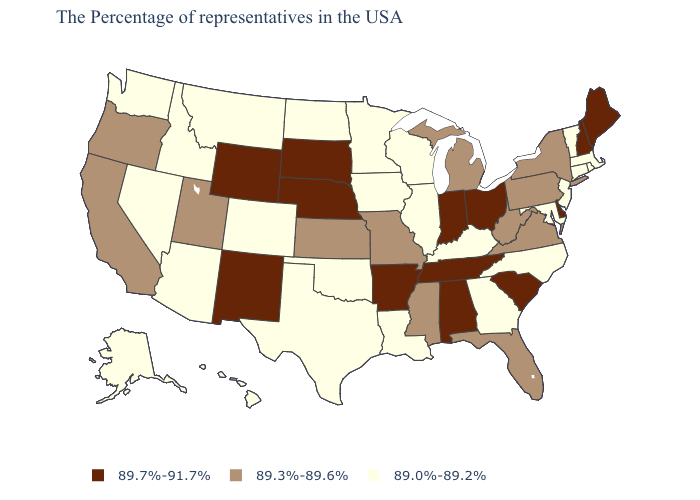Does Pennsylvania have the same value as Minnesota?
Concise answer only. No. Name the states that have a value in the range 89.3%-89.6%?
Give a very brief answer. New York, Pennsylvania, Virginia, West Virginia, Florida, Michigan, Mississippi, Missouri, Kansas, Utah, California, Oregon. What is the value of Wisconsin?
Be succinct. 89.0%-89.2%. How many symbols are there in the legend?
Answer briefly. 3. Name the states that have a value in the range 89.3%-89.6%?
Keep it brief. New York, Pennsylvania, Virginia, West Virginia, Florida, Michigan, Mississippi, Missouri, Kansas, Utah, California, Oregon. Name the states that have a value in the range 89.3%-89.6%?
Short answer required. New York, Pennsylvania, Virginia, West Virginia, Florida, Michigan, Mississippi, Missouri, Kansas, Utah, California, Oregon. Which states have the lowest value in the USA?
Quick response, please. Massachusetts, Rhode Island, Vermont, Connecticut, New Jersey, Maryland, North Carolina, Georgia, Kentucky, Wisconsin, Illinois, Louisiana, Minnesota, Iowa, Oklahoma, Texas, North Dakota, Colorado, Montana, Arizona, Idaho, Nevada, Washington, Alaska, Hawaii. Does the first symbol in the legend represent the smallest category?
Quick response, please. No. Name the states that have a value in the range 89.0%-89.2%?
Concise answer only. Massachusetts, Rhode Island, Vermont, Connecticut, New Jersey, Maryland, North Carolina, Georgia, Kentucky, Wisconsin, Illinois, Louisiana, Minnesota, Iowa, Oklahoma, Texas, North Dakota, Colorado, Montana, Arizona, Idaho, Nevada, Washington, Alaska, Hawaii. Which states have the highest value in the USA?
Concise answer only. Maine, New Hampshire, Delaware, South Carolina, Ohio, Indiana, Alabama, Tennessee, Arkansas, Nebraska, South Dakota, Wyoming, New Mexico. Which states have the highest value in the USA?
Quick response, please. Maine, New Hampshire, Delaware, South Carolina, Ohio, Indiana, Alabama, Tennessee, Arkansas, Nebraska, South Dakota, Wyoming, New Mexico. Name the states that have a value in the range 89.7%-91.7%?
Concise answer only. Maine, New Hampshire, Delaware, South Carolina, Ohio, Indiana, Alabama, Tennessee, Arkansas, Nebraska, South Dakota, Wyoming, New Mexico. What is the value of Rhode Island?
Keep it brief. 89.0%-89.2%. Does South Dakota have a higher value than New Mexico?
Quick response, please. No. What is the value of Minnesota?
Quick response, please. 89.0%-89.2%. 